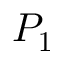Convert formula to latex. <formula><loc_0><loc_0><loc_500><loc_500>P _ { 1 }</formula> 